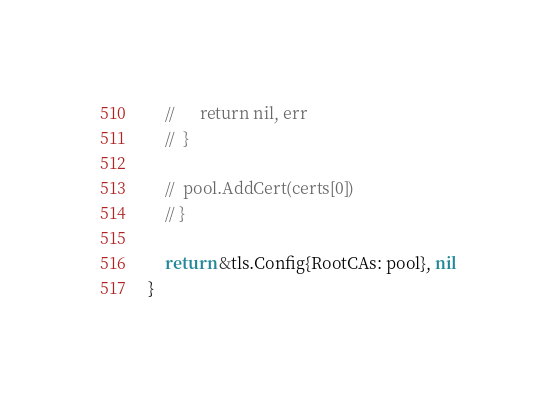<code> <loc_0><loc_0><loc_500><loc_500><_Go_>	// 		return nil, err
	// 	}

	// 	pool.AddCert(certs[0])
	// }

	return &tls.Config{RootCAs: pool}, nil
}
</code> 